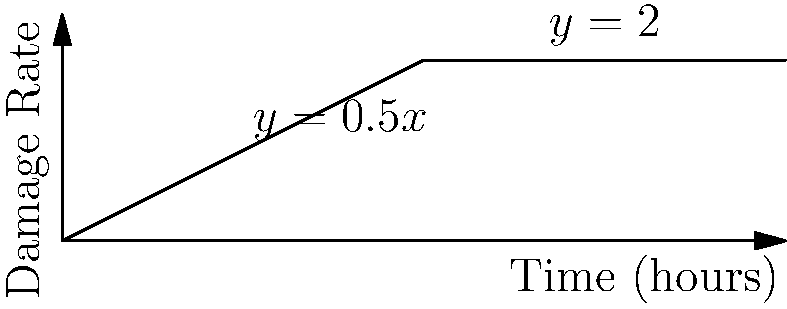The graph shows the rate of retinal cell damage due to blue light exposure over time. The damage rate (in arbitrary units) is given by the piecewise function:

$$f(t) = \begin{cases}
0.5t & \text{if } 0 \leq t < 4 \\
2 & \text{if } 4 \leq t \leq 8
\end{cases}$$

where $t$ is time in hours. Calculate the cumulative damage to retinal cells over the 8-hour period. To calculate the cumulative damage, we need to integrate the piecewise function over the entire 8-hour period. We'll do this in two parts:

1. For $0 \leq t < 4$:
   $$\int_0^4 0.5t \, dt = 0.5 \cdot \frac{t^2}{2} \bigg|_0^4 = 0.5 \cdot \frac{16}{2} - 0 = 4$$

2. For $4 \leq t \leq 8$:
   $$\int_4^8 2 \, dt = 2t \bigg|_4^8 = 16 - 8 = 8$$

3. Sum the results from both intervals:
   Total cumulative damage = $4 + 8 = 12$

Therefore, the cumulative damage to retinal cells over the 8-hour period is 12 arbitrary units.
Answer: 12 units 